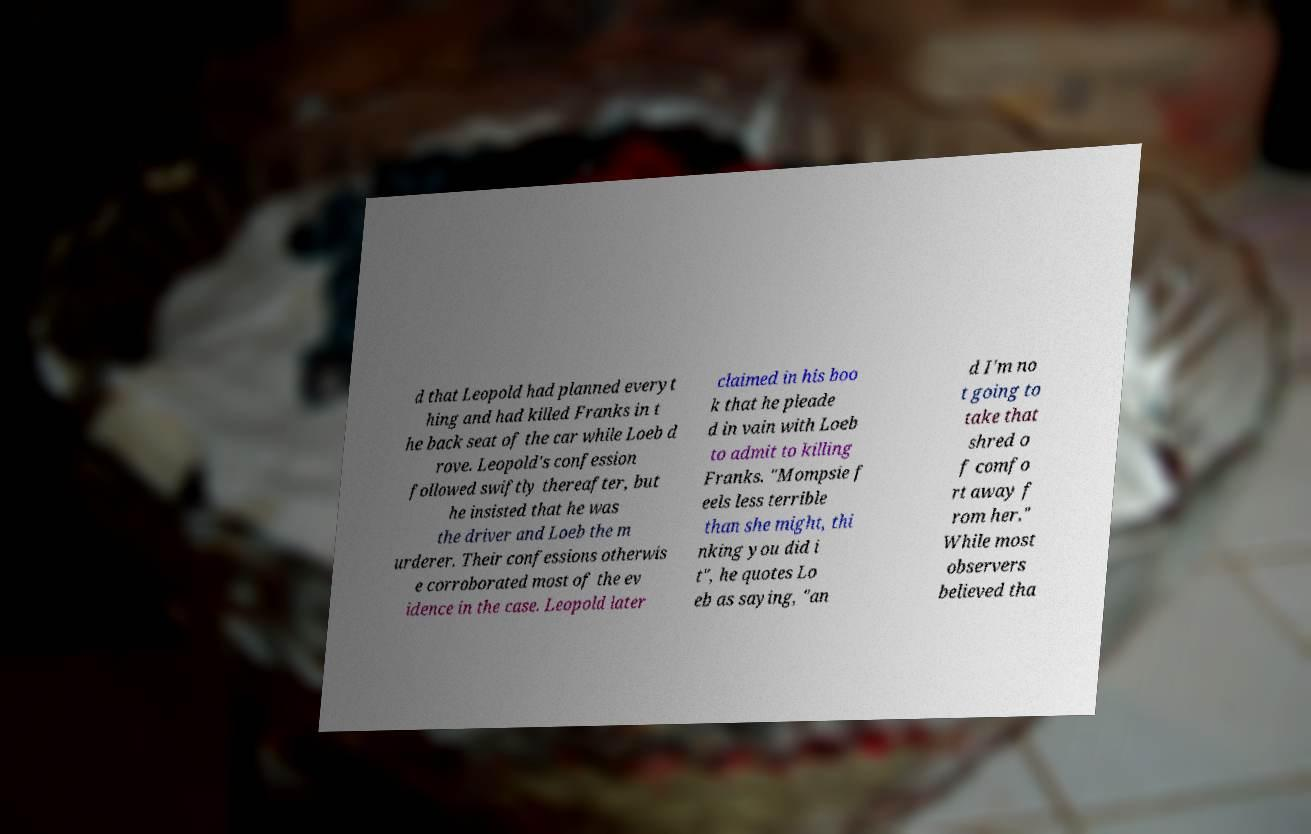I need the written content from this picture converted into text. Can you do that? d that Leopold had planned everyt hing and had killed Franks in t he back seat of the car while Loeb d rove. Leopold's confession followed swiftly thereafter, but he insisted that he was the driver and Loeb the m urderer. Their confessions otherwis e corroborated most of the ev idence in the case. Leopold later claimed in his boo k that he pleade d in vain with Loeb to admit to killing Franks. "Mompsie f eels less terrible than she might, thi nking you did i t", he quotes Lo eb as saying, "an d I'm no t going to take that shred o f comfo rt away f rom her." While most observers believed tha 